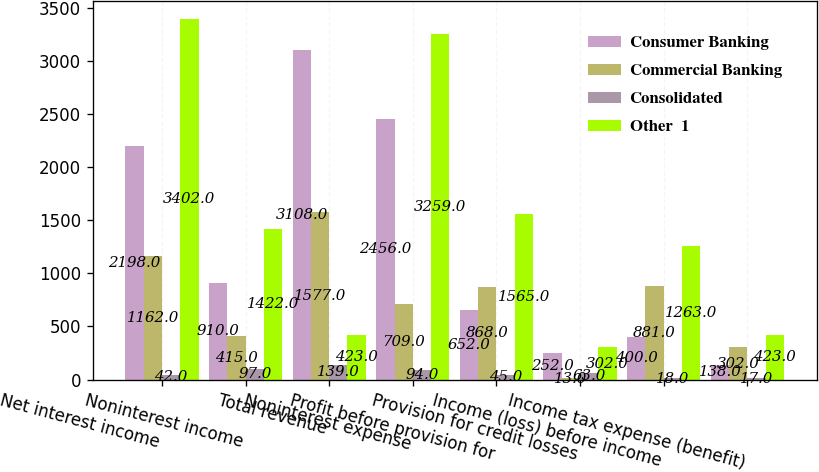Convert chart. <chart><loc_0><loc_0><loc_500><loc_500><stacked_bar_chart><ecel><fcel>Net interest income<fcel>Noninterest income<fcel>Total revenue<fcel>Noninterest expense<fcel>Profit before provision for<fcel>Provision for credit losses<fcel>Income (loss) before income<fcel>Income tax expense (benefit)<nl><fcel>Consumer Banking<fcel>2198<fcel>910<fcel>3108<fcel>2456<fcel>652<fcel>252<fcel>400<fcel>138<nl><fcel>Commercial Banking<fcel>1162<fcel>415<fcel>1577<fcel>709<fcel>868<fcel>13<fcel>881<fcel>302<nl><fcel>Consolidated<fcel>42<fcel>97<fcel>139<fcel>94<fcel>45<fcel>63<fcel>18<fcel>17<nl><fcel>Other  1<fcel>3402<fcel>1422<fcel>423<fcel>3259<fcel>1565<fcel>302<fcel>1263<fcel>423<nl></chart> 